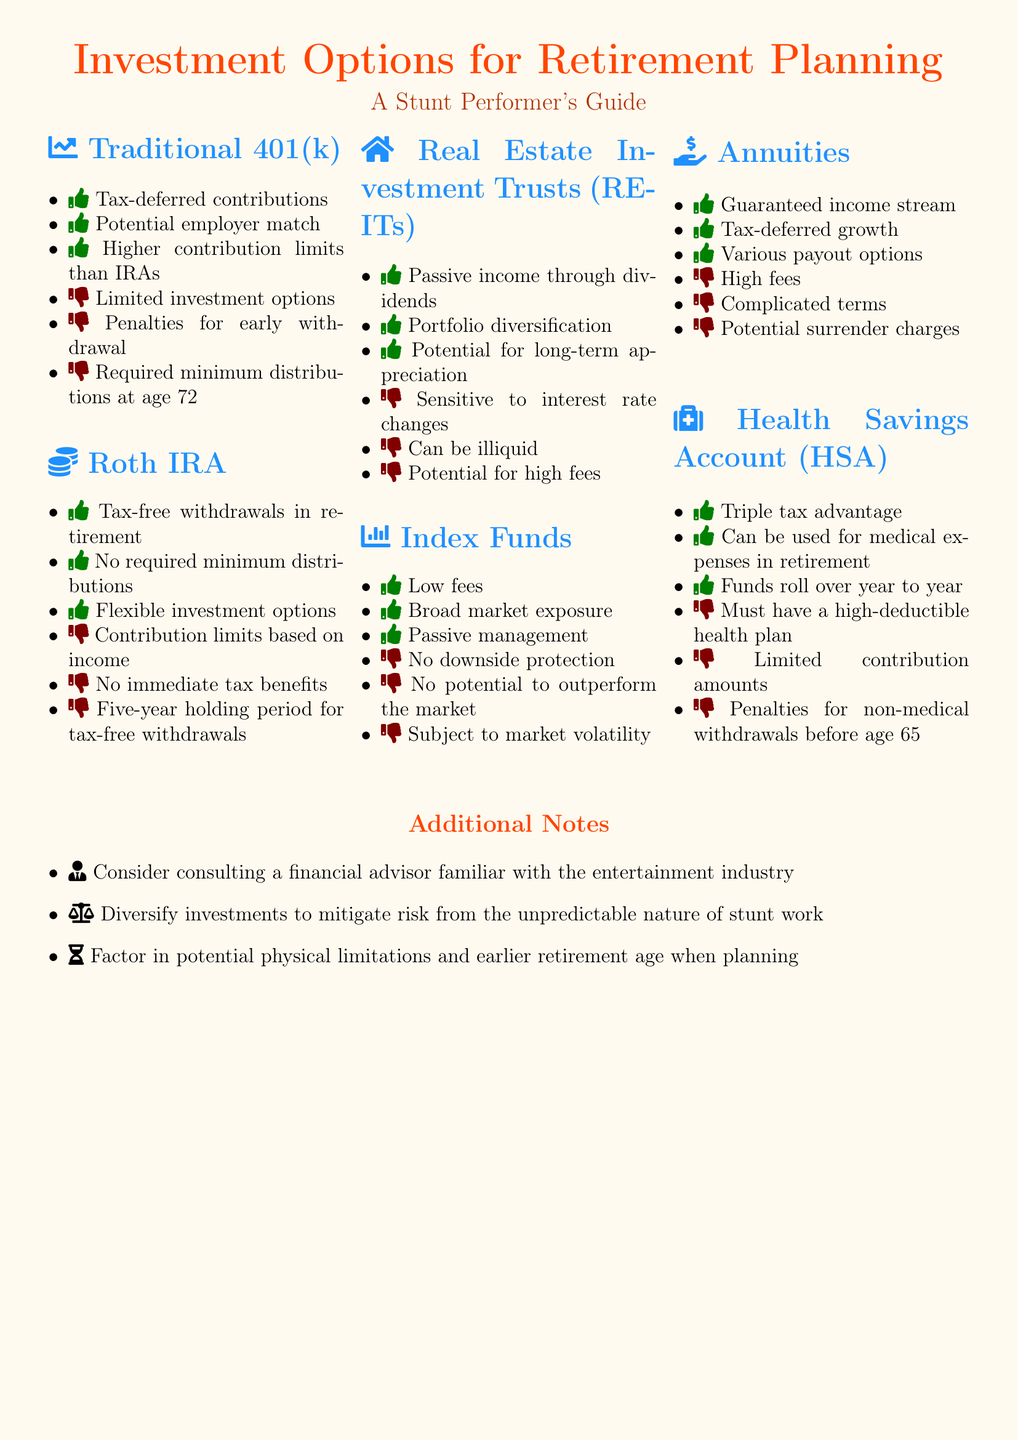What are the pros of a Traditional 401(k)? The pros listed for a Traditional 401(k) include tax-deferred contributions, potential employer match, and higher contribution limits than IRAs.
Answer: Tax-deferred contributions, potential employer match, higher contribution limits than IRAs What are the cons of a Roth IRA? The cons listed for a Roth IRA include contribution limits based on income, no immediate tax benefits, and a five-year holding period for tax-free withdrawals.
Answer: Contribution limits based on income, no immediate tax benefits, five-year holding period for tax-free withdrawals How many pros are listed for Index Funds? The document lists three pros for Index Funds: low fees, broad market exposure, and passive management.
Answer: Three What is a key benefit of Health Savings Account (HSA)? One of the key benefits mentioned for HSA is the triple tax advantage.
Answer: Triple tax advantage What potential challenge is noted for Real Estate Investment Trusts (REITs)? The document states that REITs are sensitive to interest rate changes as one of the potential challenges.
Answer: Sensitive to interest rate changes What is recommended for managing investment risk in stunt work? The document recommends diversifying investments to mitigate risk.
Answer: Diversify investments At what age are required minimum distributions required for a Traditional 401(k)? The document specifies that required minimum distributions are required at age 72.
Answer: Age 72 What is a suggested action regarding financial planning? It is suggested to consult a financial advisor familiar with the entertainment industry.
Answer: Consult a financial advisor How does an annuity advantage relate to income? The document mentions that annuities provide a guaranteed income stream as an advantage.
Answer: Guaranteed income stream 